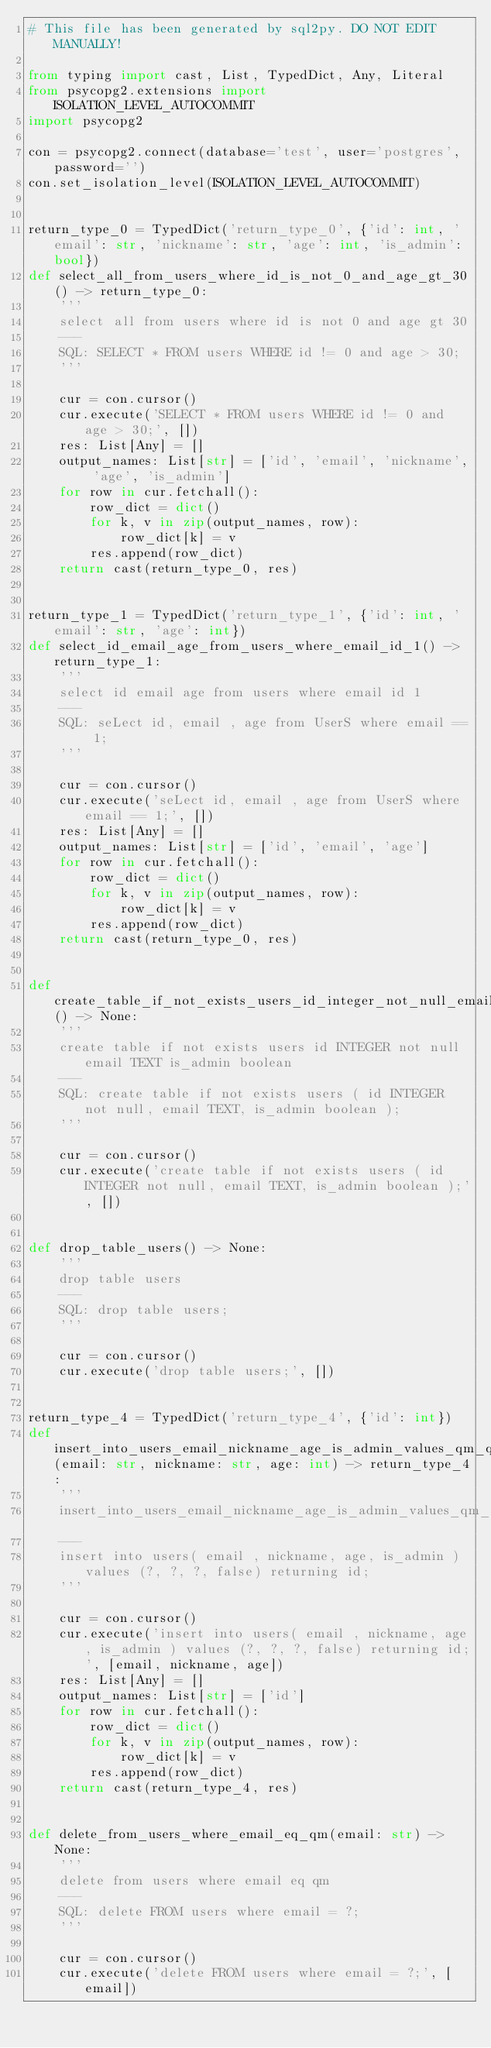<code> <loc_0><loc_0><loc_500><loc_500><_Python_># This file has been generated by sql2py. DO NOT EDIT MANUALLY!

from typing import cast, List, TypedDict, Any, Literal
from psycopg2.extensions import ISOLATION_LEVEL_AUTOCOMMIT
import psycopg2

con = psycopg2.connect(database='test', user='postgres', password='')
con.set_isolation_level(ISOLATION_LEVEL_AUTOCOMMIT)


return_type_0 = TypedDict('return_type_0', {'id': int, 'email': str, 'nickname': str, 'age': int, 'is_admin': bool})
def select_all_from_users_where_id_is_not_0_and_age_gt_30() -> return_type_0:
    '''
    select all from users where id is not 0 and age gt 30
    ---
    SQL: SELECT * FROM users WHERE id != 0 and age > 30;
    '''

    cur = con.cursor()
    cur.execute('SELECT * FROM users WHERE id != 0 and age > 30;', [])
    res: List[Any] = []
    output_names: List[str] = ['id', 'email', 'nickname', 'age', 'is_admin']
    for row in cur.fetchall():
        row_dict = dict()
        for k, v in zip(output_names, row):
            row_dict[k] = v
        res.append(row_dict)
    return cast(return_type_0, res)


return_type_1 = TypedDict('return_type_1', {'id': int, 'email': str, 'age': int})
def select_id_email_age_from_users_where_email_id_1() -> return_type_1:
    '''
    select id email age from users where email id 1
    ---
    SQL: seLect id, email , age from UserS where email == 1;
    '''

    cur = con.cursor()
    cur.execute('seLect id, email , age from UserS where email == 1;', [])
    res: List[Any] = []
    output_names: List[str] = ['id', 'email', 'age']
    for row in cur.fetchall():
        row_dict = dict()
        for k, v in zip(output_names, row):
            row_dict[k] = v
        res.append(row_dict)
    return cast(return_type_0, res)


def create_table_if_not_exists_users_id_integer_not_null_email_text_is_admin_boolean() -> None:
    '''
    create table if not exists users id INTEGER not null email TEXT is_admin boolean
    ---
    SQL: create table if not exists users ( id INTEGER not null, email TEXT, is_admin boolean );
    '''

    cur = con.cursor()
    cur.execute('create table if not exists users ( id INTEGER not null, email TEXT, is_admin boolean );', [])


def drop_table_users() -> None:
    '''
    drop table users
    ---
    SQL: drop table users;
    '''

    cur = con.cursor()
    cur.execute('drop table users;', [])


return_type_4 = TypedDict('return_type_4', {'id': int})
def insert_into_users_email_nickname_age_is_admin_values_qm_qm_qm_false_returning_id(email: str, nickname: str, age: int) -> return_type_4:
    '''
    insert_into_users_email_nickname_age_is_admin_values_qm_qm_qm_false_returning_id
    ---
    insert into users( email , nickname, age, is_admin ) values (?, ?, ?, false) returning id;
    '''

    cur = con.cursor()
    cur.execute('insert into users( email , nickname, age, is_admin ) values (?, ?, ?, false) returning id;', [email, nickname, age])
    res: List[Any] = []
    output_names: List[str] = ['id']
    for row in cur.fetchall():
        row_dict = dict()
        for k, v in zip(output_names, row):
            row_dict[k] = v
        res.append(row_dict)
    return cast(return_type_4, res)


def delete_from_users_where_email_eq_qm(email: str) -> None:
    '''
    delete from users where email eq qm
    ---
    SQL: delete FROM users where email = ?;
    '''

    cur = con.cursor()
    cur.execute('delete FROM users where email = ?;', [email])
</code> 